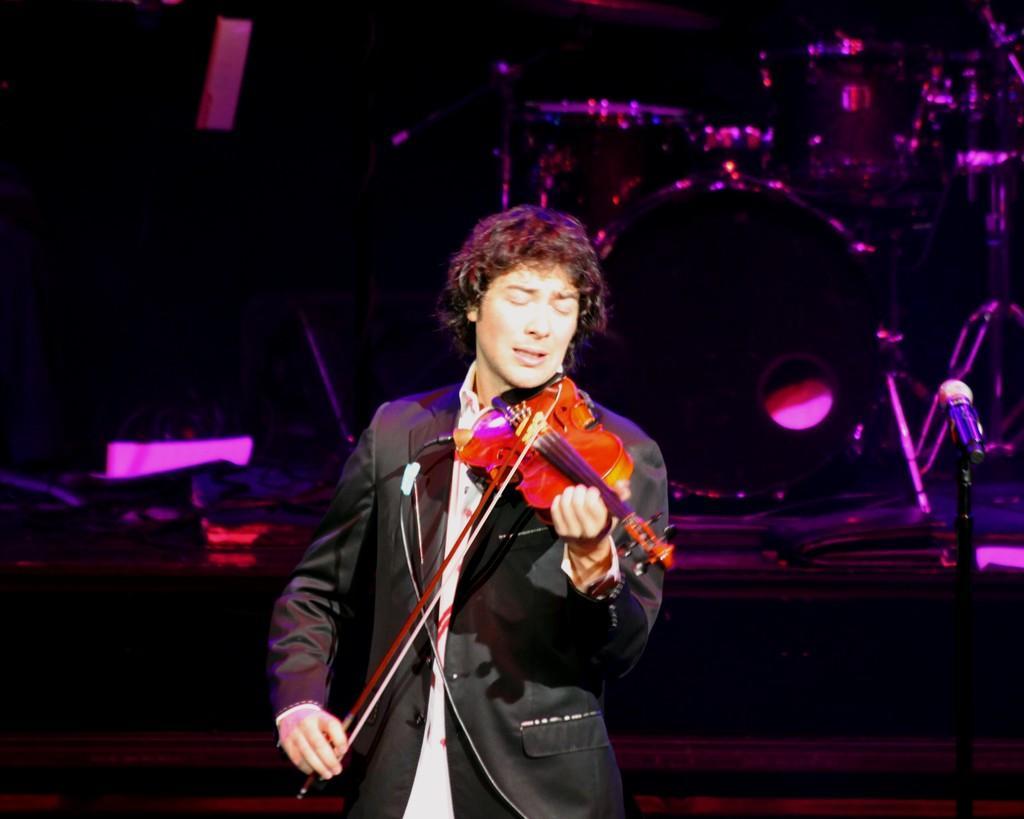Describe this image in one or two sentences. In this image, In the middle there is a man standing and holding a music instrument in yellow color, he is singing in microphone. 